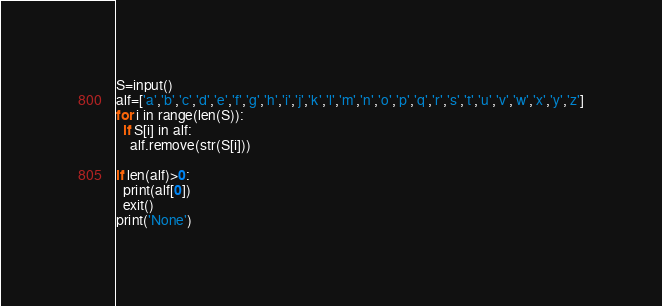Convert code to text. <code><loc_0><loc_0><loc_500><loc_500><_Python_>S=input()
alf=['a','b','c','d','e','f','g','h','i','j','k','l','m','n','o','p','q','r','s','t','u','v','w','x','y','z']
for i in range(len(S)):
  if S[i] in alf:
    alf.remove(str(S[i]))
  
if len(alf)>0:
  print(alf[0])
  exit()
print('None')</code> 